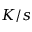Convert formula to latex. <formula><loc_0><loc_0><loc_500><loc_500>K / s</formula> 